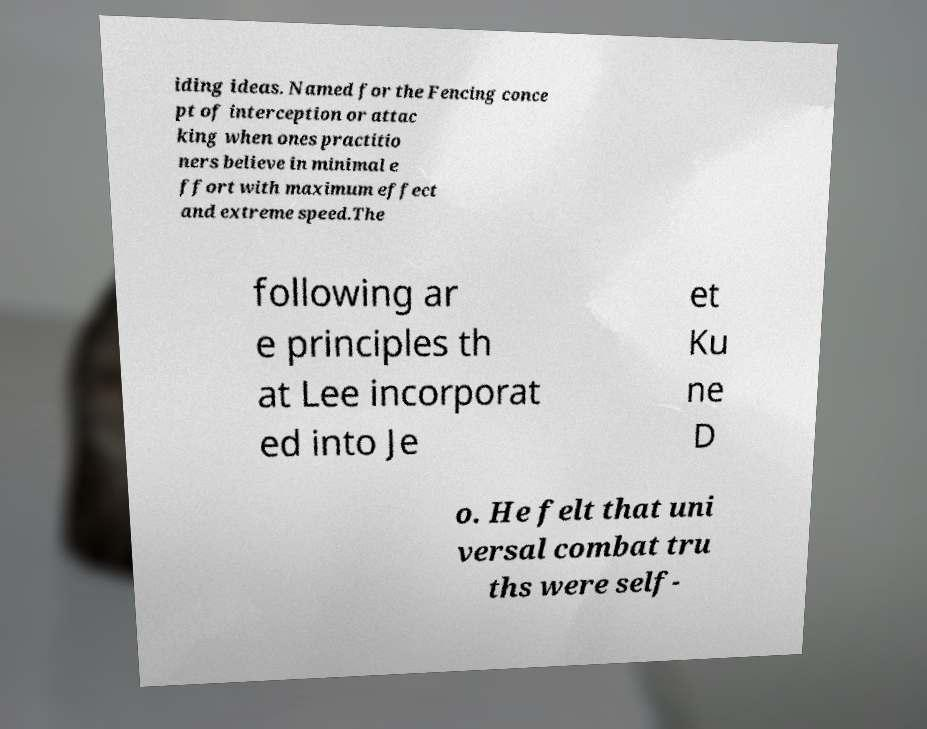Please read and relay the text visible in this image. What does it say? iding ideas. Named for the Fencing conce pt of interception or attac king when ones practitio ners believe in minimal e ffort with maximum effect and extreme speed.The following ar e principles th at Lee incorporat ed into Je et Ku ne D o. He felt that uni versal combat tru ths were self- 